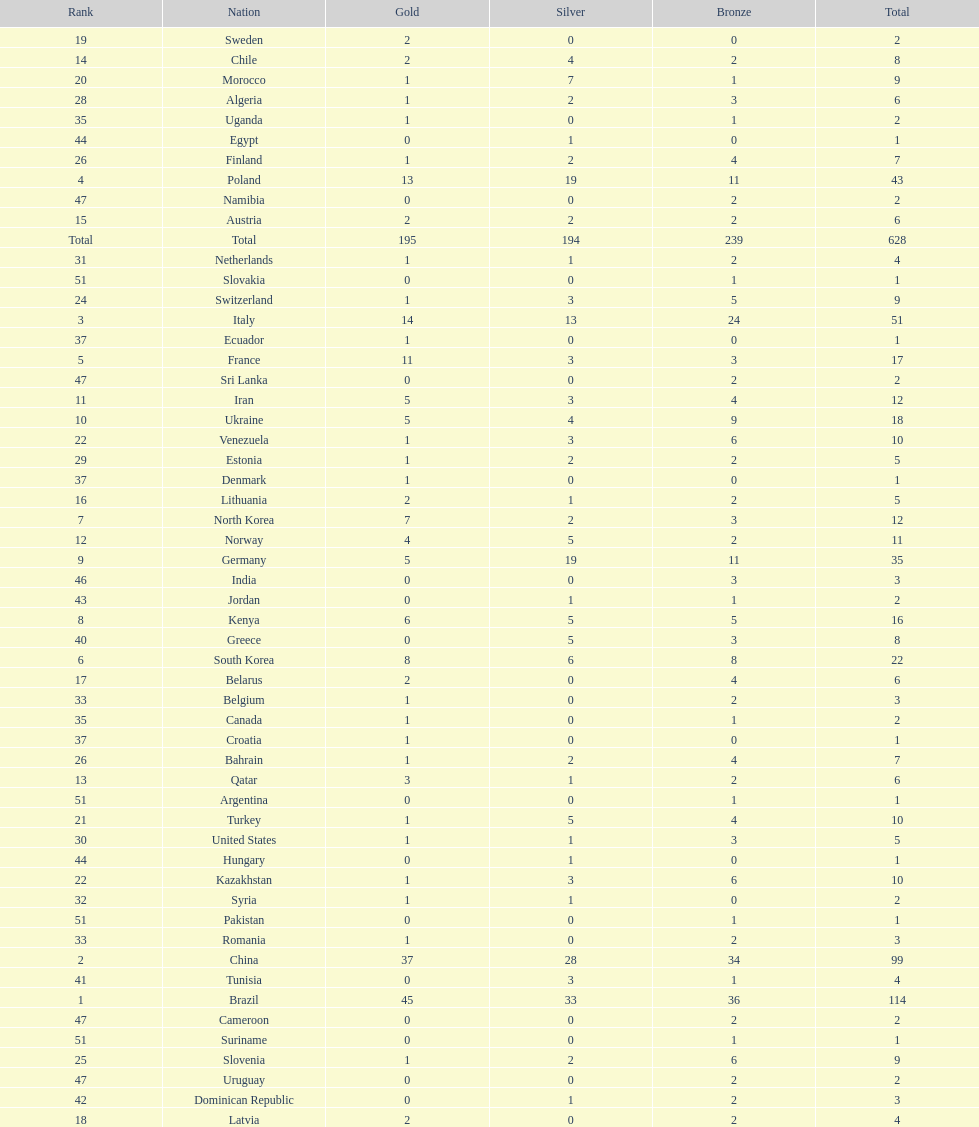Did italy or norway have 51 total medals? Italy. 